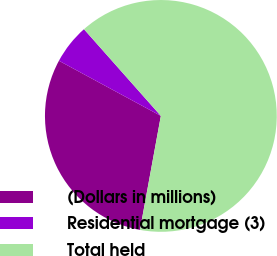<chart> <loc_0><loc_0><loc_500><loc_500><pie_chart><fcel>(Dollars in millions)<fcel>Residential mortgage (3)<fcel>Total held<nl><fcel>30.01%<fcel>5.56%<fcel>64.43%<nl></chart> 